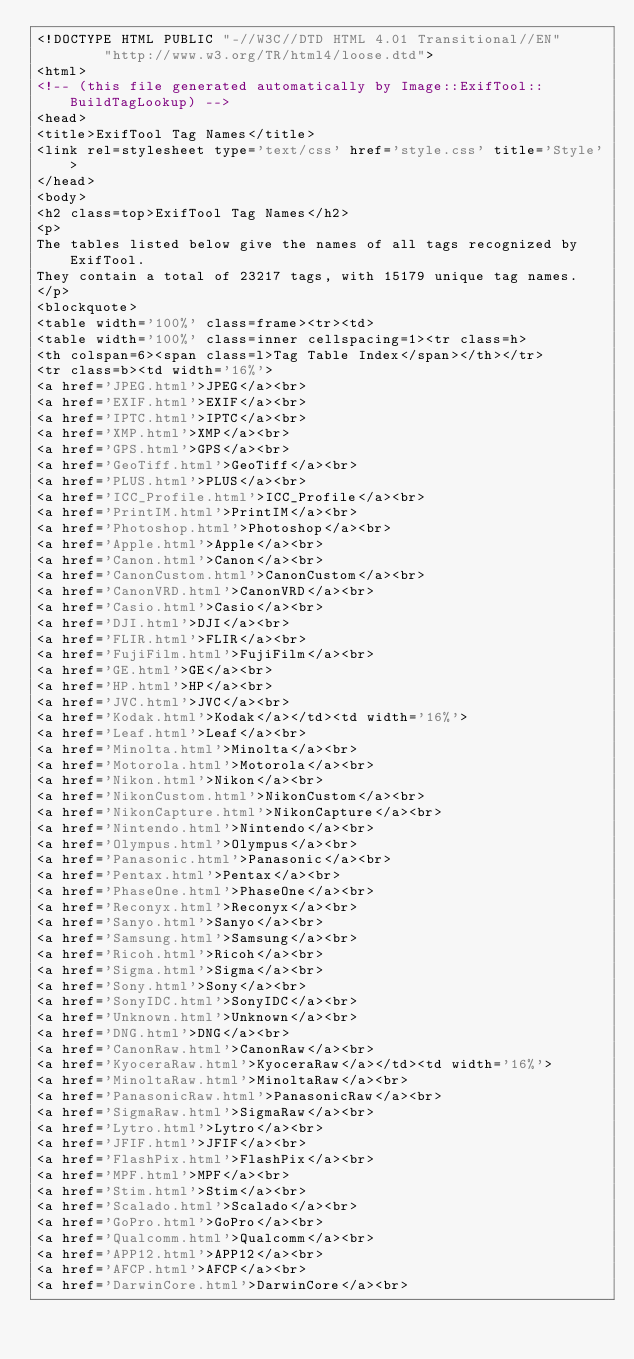<code> <loc_0><loc_0><loc_500><loc_500><_HTML_><!DOCTYPE HTML PUBLIC "-//W3C//DTD HTML 4.01 Transitional//EN"
        "http://www.w3.org/TR/html4/loose.dtd">
<html>
<!-- (this file generated automatically by Image::ExifTool::BuildTagLookup) -->
<head>
<title>ExifTool Tag Names</title>
<link rel=stylesheet type='text/css' href='style.css' title='Style'>
</head>
<body>
<h2 class=top>ExifTool Tag Names</h2>
<p>
The tables listed below give the names of all tags recognized by ExifTool.
They contain a total of 23217 tags, with 15179 unique tag names.
</p>
<blockquote>
<table width='100%' class=frame><tr><td>
<table width='100%' class=inner cellspacing=1><tr class=h>
<th colspan=6><span class=l>Tag Table Index</span></th></tr>
<tr class=b><td width='16%'>
<a href='JPEG.html'>JPEG</a><br>
<a href='EXIF.html'>EXIF</a><br>
<a href='IPTC.html'>IPTC</a><br>
<a href='XMP.html'>XMP</a><br>
<a href='GPS.html'>GPS</a><br>
<a href='GeoTiff.html'>GeoTiff</a><br>
<a href='PLUS.html'>PLUS</a><br>
<a href='ICC_Profile.html'>ICC_Profile</a><br>
<a href='PrintIM.html'>PrintIM</a><br>
<a href='Photoshop.html'>Photoshop</a><br>
<a href='Apple.html'>Apple</a><br>
<a href='Canon.html'>Canon</a><br>
<a href='CanonCustom.html'>CanonCustom</a><br>
<a href='CanonVRD.html'>CanonVRD</a><br>
<a href='Casio.html'>Casio</a><br>
<a href='DJI.html'>DJI</a><br>
<a href='FLIR.html'>FLIR</a><br>
<a href='FujiFilm.html'>FujiFilm</a><br>
<a href='GE.html'>GE</a><br>
<a href='HP.html'>HP</a><br>
<a href='JVC.html'>JVC</a><br>
<a href='Kodak.html'>Kodak</a></td><td width='16%'>
<a href='Leaf.html'>Leaf</a><br>
<a href='Minolta.html'>Minolta</a><br>
<a href='Motorola.html'>Motorola</a><br>
<a href='Nikon.html'>Nikon</a><br>
<a href='NikonCustom.html'>NikonCustom</a><br>
<a href='NikonCapture.html'>NikonCapture</a><br>
<a href='Nintendo.html'>Nintendo</a><br>
<a href='Olympus.html'>Olympus</a><br>
<a href='Panasonic.html'>Panasonic</a><br>
<a href='Pentax.html'>Pentax</a><br>
<a href='PhaseOne.html'>PhaseOne</a><br>
<a href='Reconyx.html'>Reconyx</a><br>
<a href='Sanyo.html'>Sanyo</a><br>
<a href='Samsung.html'>Samsung</a><br>
<a href='Ricoh.html'>Ricoh</a><br>
<a href='Sigma.html'>Sigma</a><br>
<a href='Sony.html'>Sony</a><br>
<a href='SonyIDC.html'>SonyIDC</a><br>
<a href='Unknown.html'>Unknown</a><br>
<a href='DNG.html'>DNG</a><br>
<a href='CanonRaw.html'>CanonRaw</a><br>
<a href='KyoceraRaw.html'>KyoceraRaw</a></td><td width='16%'>
<a href='MinoltaRaw.html'>MinoltaRaw</a><br>
<a href='PanasonicRaw.html'>PanasonicRaw</a><br>
<a href='SigmaRaw.html'>SigmaRaw</a><br>
<a href='Lytro.html'>Lytro</a><br>
<a href='JFIF.html'>JFIF</a><br>
<a href='FlashPix.html'>FlashPix</a><br>
<a href='MPF.html'>MPF</a><br>
<a href='Stim.html'>Stim</a><br>
<a href='Scalado.html'>Scalado</a><br>
<a href='GoPro.html'>GoPro</a><br>
<a href='Qualcomm.html'>Qualcomm</a><br>
<a href='APP12.html'>APP12</a><br>
<a href='AFCP.html'>AFCP</a><br>
<a href='DarwinCore.html'>DarwinCore</a><br></code> 